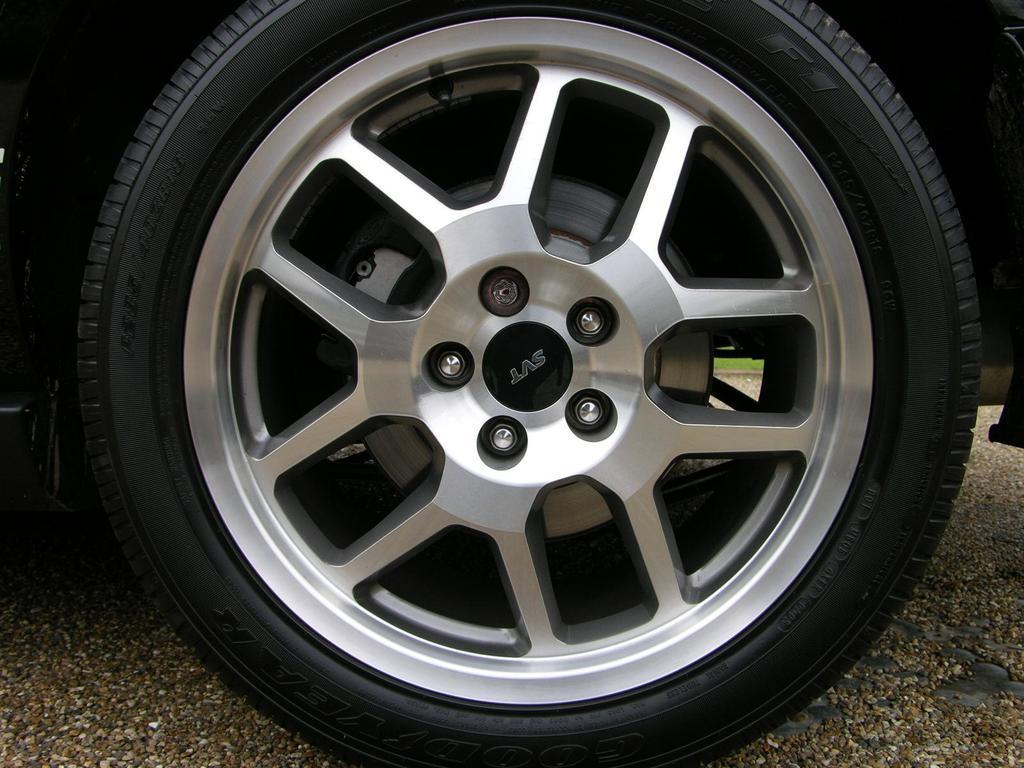Describe this image in one or two sentences. In this image in the front there is a tyre. In the background there is grass on the ground. 